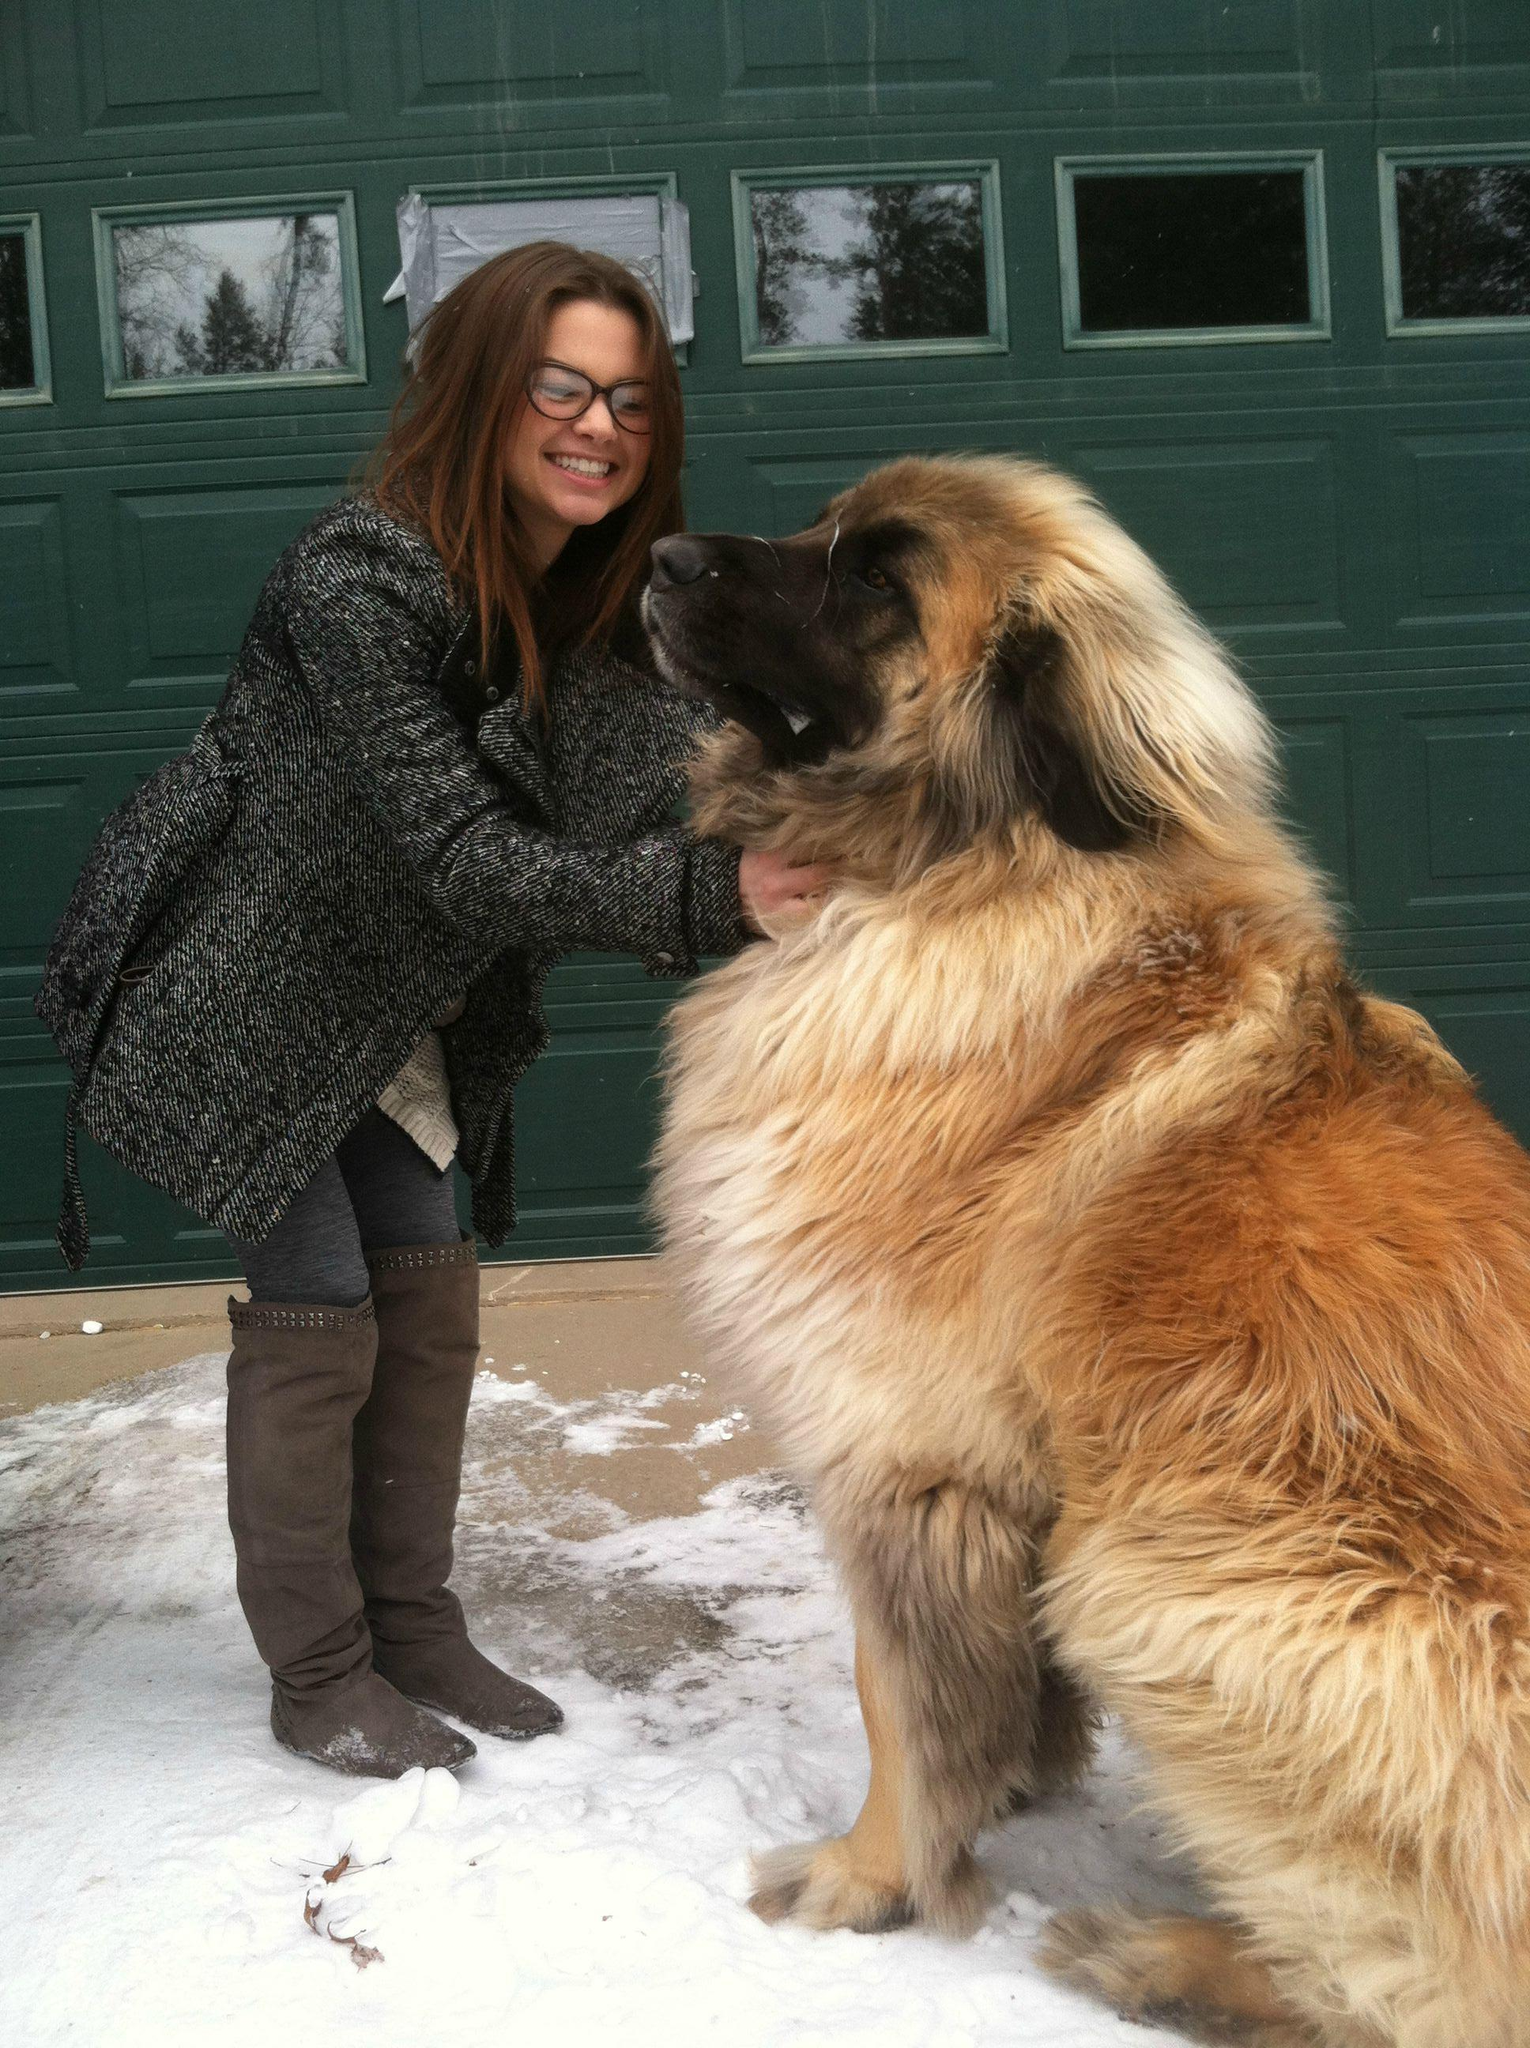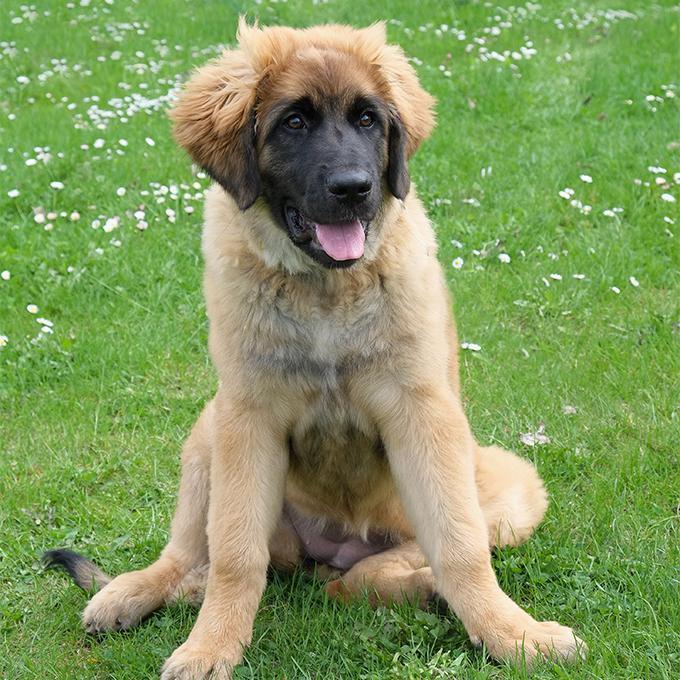The first image is the image on the left, the second image is the image on the right. Considering the images on both sides, is "There is more than one dog in one of the images." valid? Answer yes or no. No. 